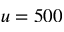<formula> <loc_0><loc_0><loc_500><loc_500>u = 5 0 0</formula> 